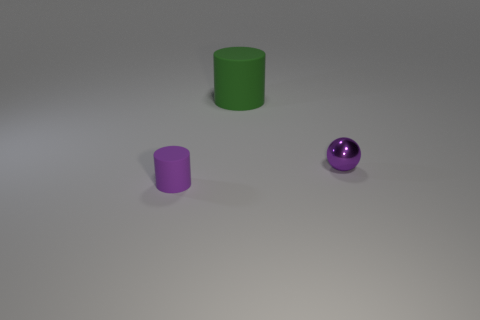Are there any other things that are the same size as the green cylinder?
Give a very brief answer. No. What number of other objects are there of the same shape as the purple metallic thing?
Offer a very short reply. 0. What size is the green matte thing?
Keep it short and to the point. Large. What size is the object that is both left of the tiny purple metal thing and in front of the green rubber cylinder?
Give a very brief answer. Small. There is a thing that is in front of the tiny purple metallic sphere; what shape is it?
Provide a short and direct response. Cylinder. Do the green cylinder and the small cylinder left of the purple metallic sphere have the same material?
Offer a terse response. Yes. Does the large rubber object have the same shape as the shiny thing?
Provide a succinct answer. No. There is another small object that is the same shape as the green matte object; what is it made of?
Make the answer very short. Rubber. What is the color of the thing that is in front of the green cylinder and to the left of the purple metal thing?
Your answer should be very brief. Purple. What is the color of the tiny ball?
Your answer should be compact. Purple. 